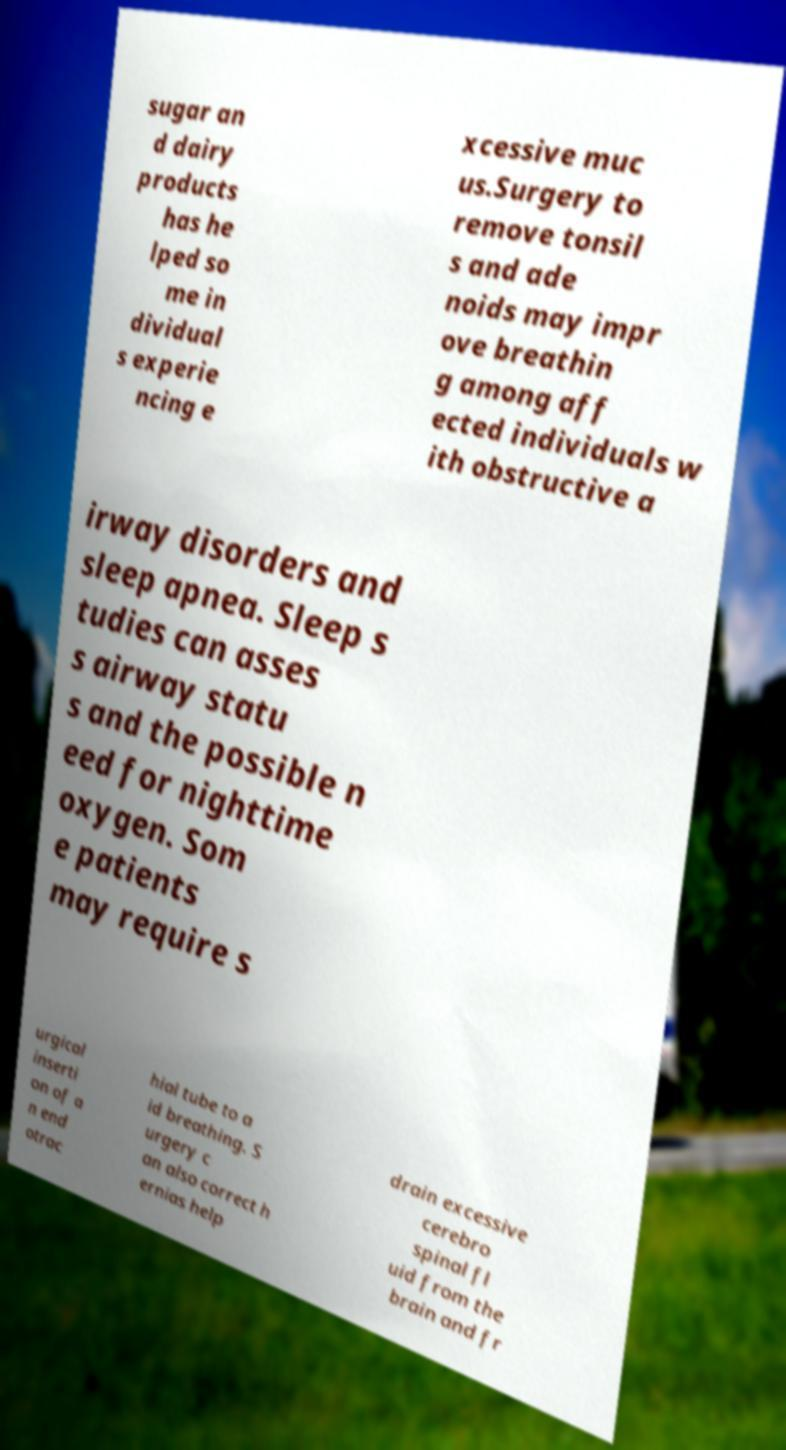Please identify and transcribe the text found in this image. sugar an d dairy products has he lped so me in dividual s experie ncing e xcessive muc us.Surgery to remove tonsil s and ade noids may impr ove breathin g among aff ected individuals w ith obstructive a irway disorders and sleep apnea. Sleep s tudies can asses s airway statu s and the possible n eed for nighttime oxygen. Som e patients may require s urgical inserti on of a n end otrac hial tube to a id breathing. S urgery c an also correct h ernias help drain excessive cerebro spinal fl uid from the brain and fr 